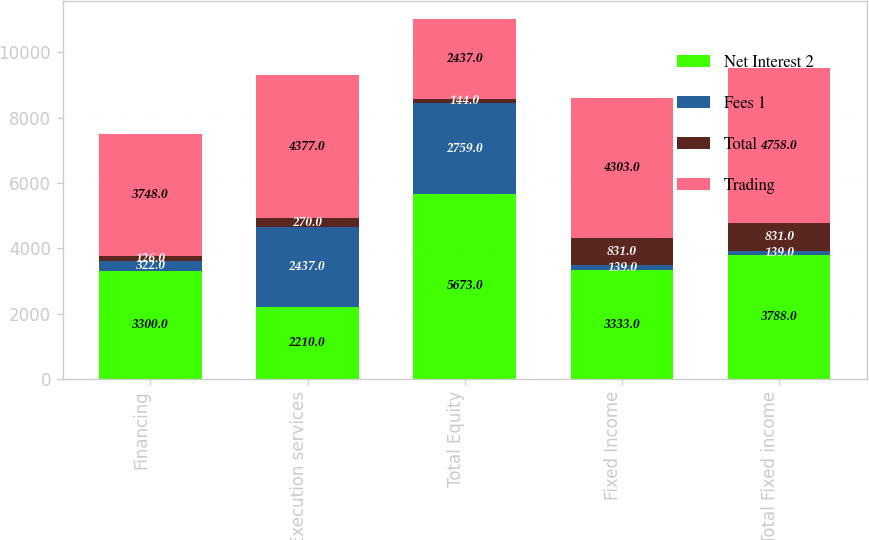<chart> <loc_0><loc_0><loc_500><loc_500><stacked_bar_chart><ecel><fcel>Financing<fcel>Execution services<fcel>Total Equity<fcel>Fixed Income<fcel>Total Fixed income<nl><fcel>Net Interest 2<fcel>3300<fcel>2210<fcel>5673<fcel>3333<fcel>3788<nl><fcel>Fees 1<fcel>322<fcel>2437<fcel>2759<fcel>139<fcel>139<nl><fcel>Total<fcel>126<fcel>270<fcel>144<fcel>831<fcel>831<nl><fcel>Trading<fcel>3748<fcel>4377<fcel>2437<fcel>4303<fcel>4758<nl></chart> 